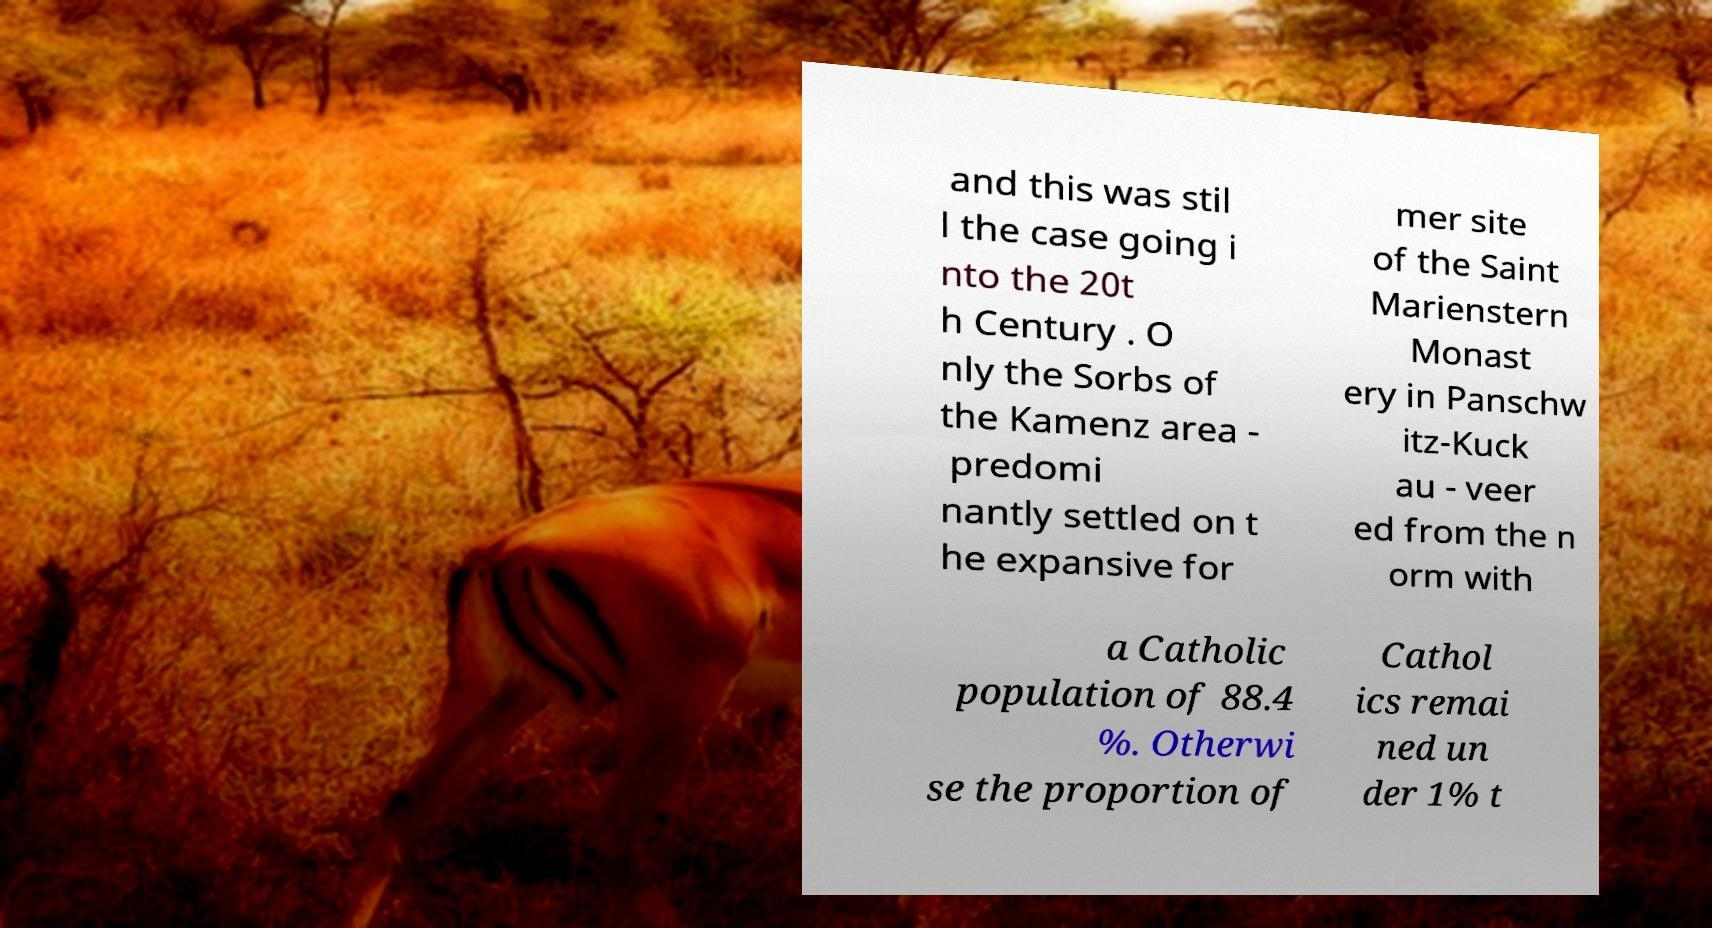I need the written content from this picture converted into text. Can you do that? and this was stil l the case going i nto the 20t h Century . O nly the Sorbs of the Kamenz area - predomi nantly settled on t he expansive for mer site of the Saint Marienstern Monast ery in Panschw itz-Kuck au - veer ed from the n orm with a Catholic population of 88.4 %. Otherwi se the proportion of Cathol ics remai ned un der 1% t 